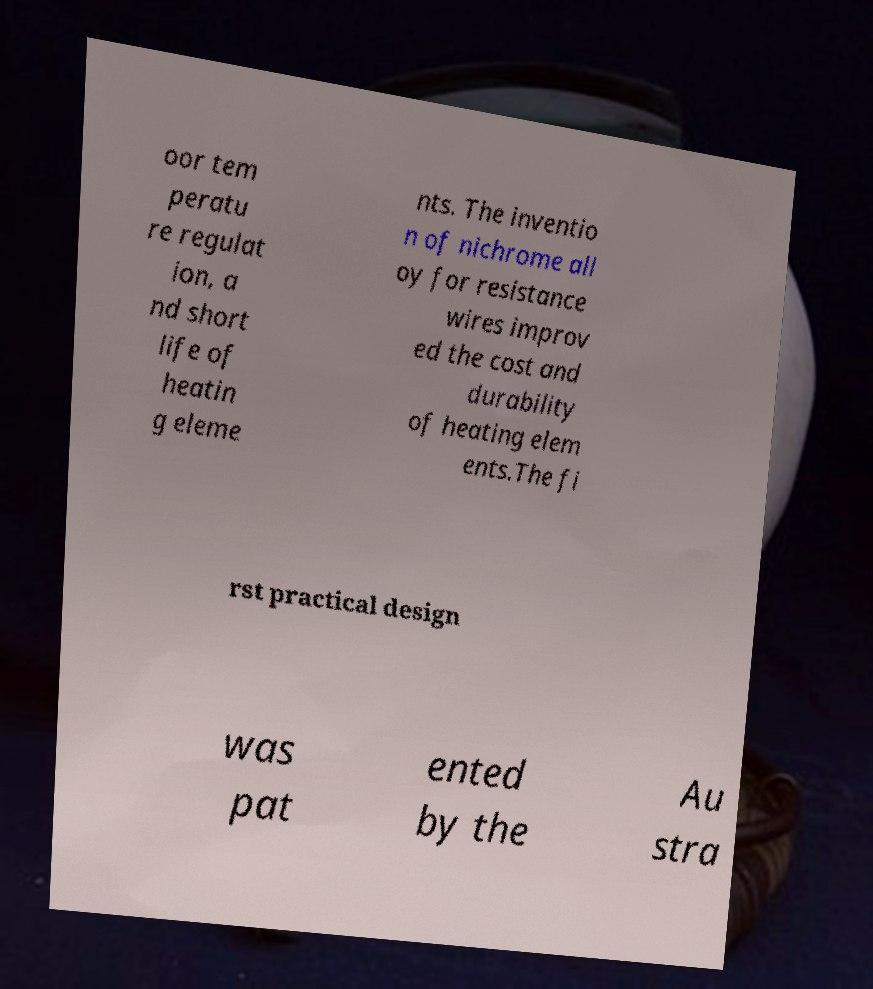Can you accurately transcribe the text from the provided image for me? oor tem peratu re regulat ion, a nd short life of heatin g eleme nts. The inventio n of nichrome all oy for resistance wires improv ed the cost and durability of heating elem ents.The fi rst practical design was pat ented by the Au stra 